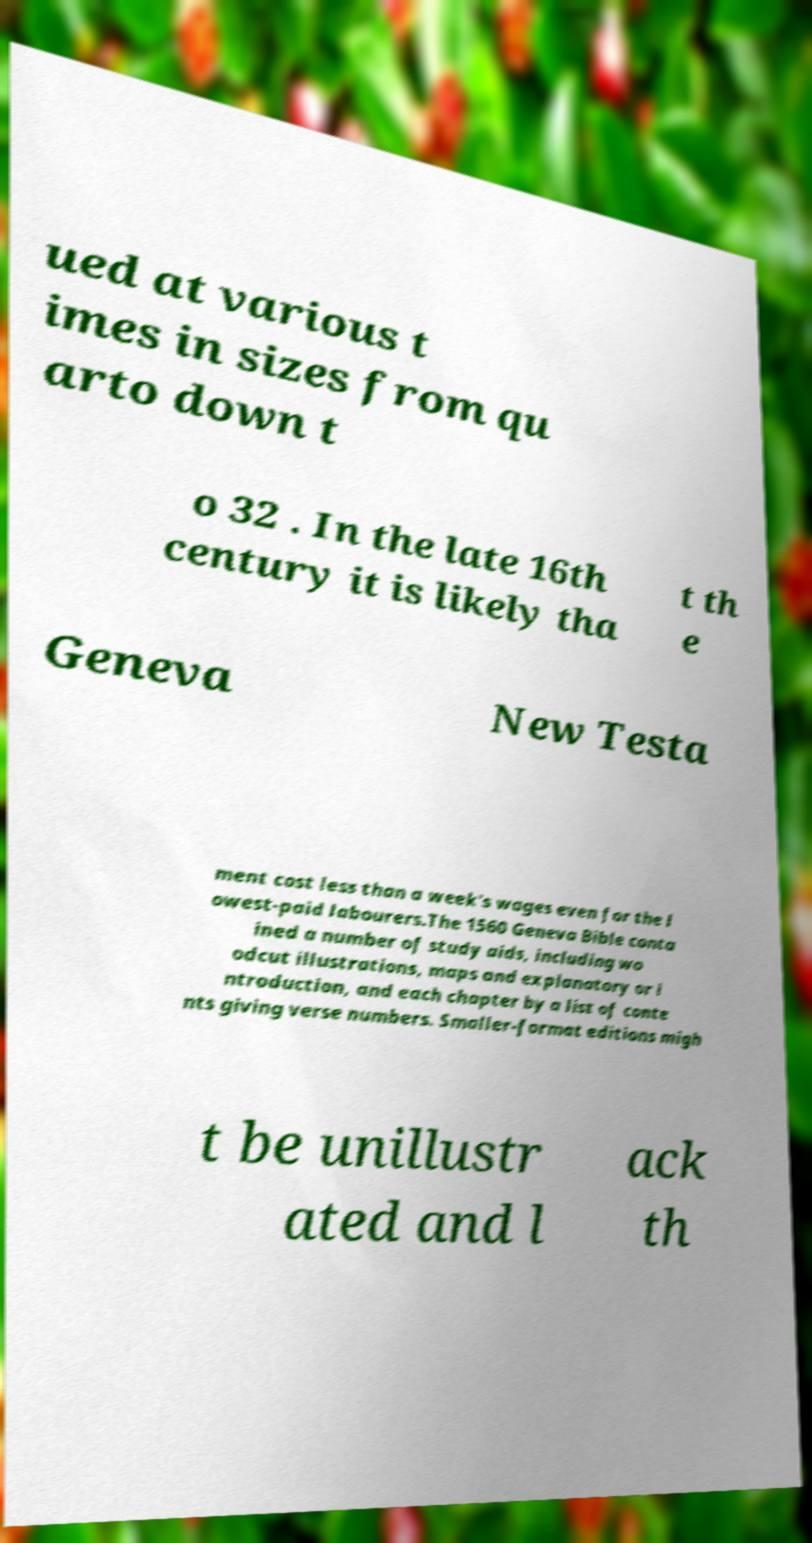I need the written content from this picture converted into text. Can you do that? ued at various t imes in sizes from qu arto down t o 32 . In the late 16th century it is likely tha t th e Geneva New Testa ment cost less than a week's wages even for the l owest-paid labourers.The 1560 Geneva Bible conta ined a number of study aids, including wo odcut illustrations, maps and explanatory or i ntroduction, and each chapter by a list of conte nts giving verse numbers. Smaller-format editions migh t be unillustr ated and l ack th 